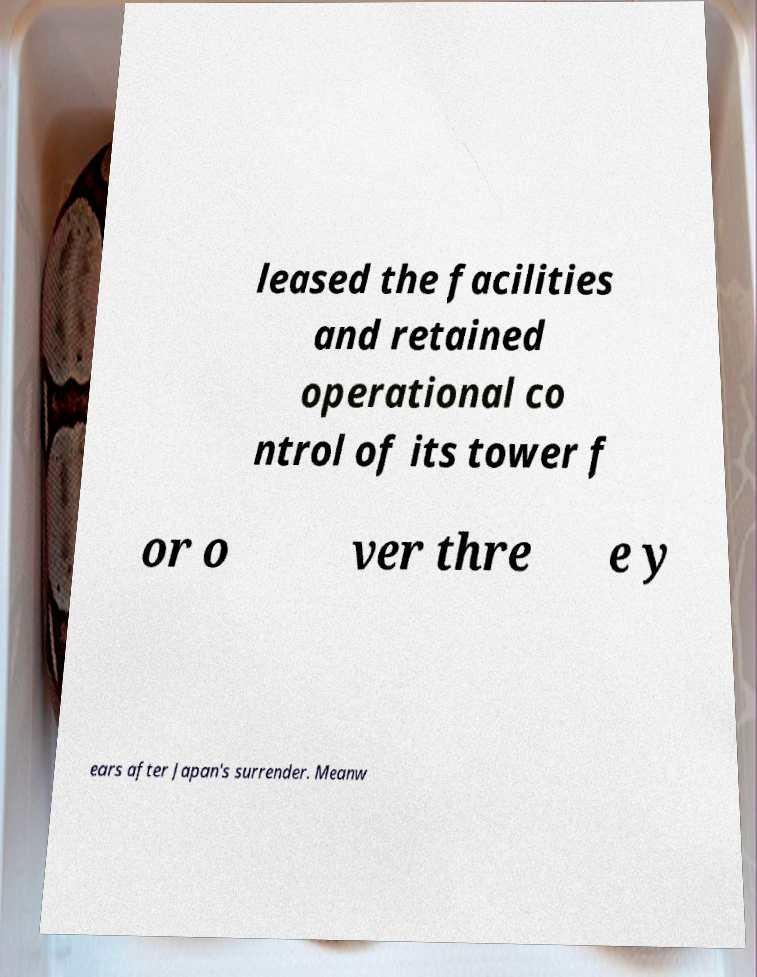Could you extract and type out the text from this image? leased the facilities and retained operational co ntrol of its tower f or o ver thre e y ears after Japan's surrender. Meanw 